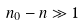<formula> <loc_0><loc_0><loc_500><loc_500>n _ { 0 } - n \gg 1</formula> 